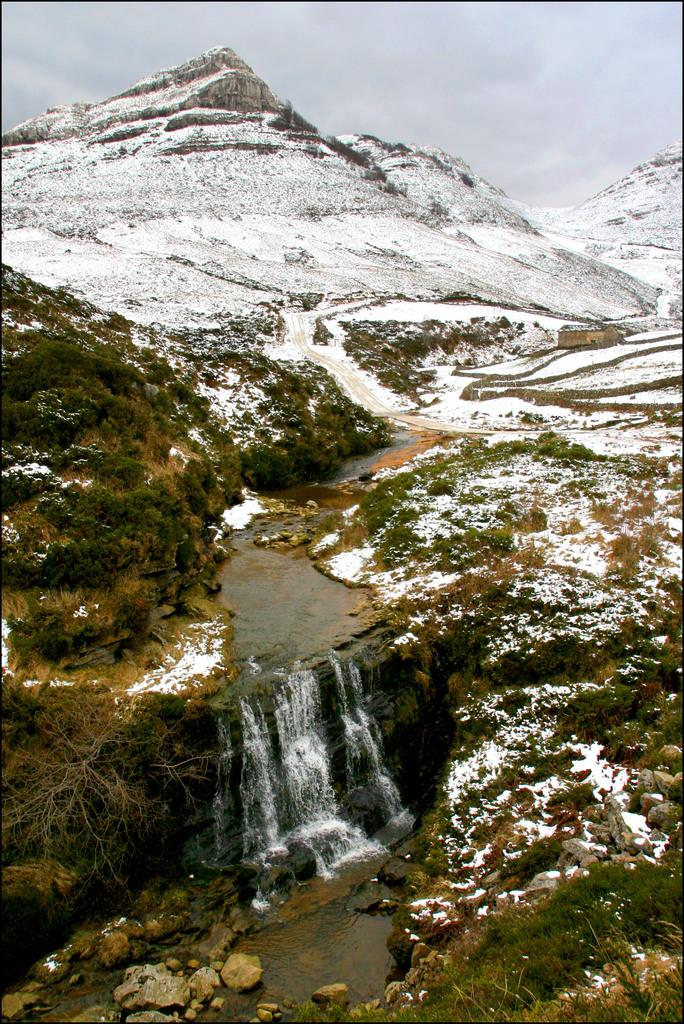What types of vegetation can be seen in the foreground of the picture? There are shrubs and trees in the foreground of the picture. What other elements are present in the foreground of the picture? There are rocks and a waterfall in the foreground of the picture. What is the terrain like in the middle of the picture? There are mountains and a road in the middle of the picture. What is the weather like in the foreground and middle of the picture? There is snow in both the foreground and middle of the picture. What can be seen in the sky at the top of the picture? The sky is visible at the top of the picture. How many bricks are used to build the part of the road in the middle of the picture? There is no mention of bricks or a specific part of the road in the image, so it is not possible to determine the number of bricks used. Can you tell me how many people are driving on the road in the middle of the picture? There are no people or vehicles visible on the road in the middle of the picture. 